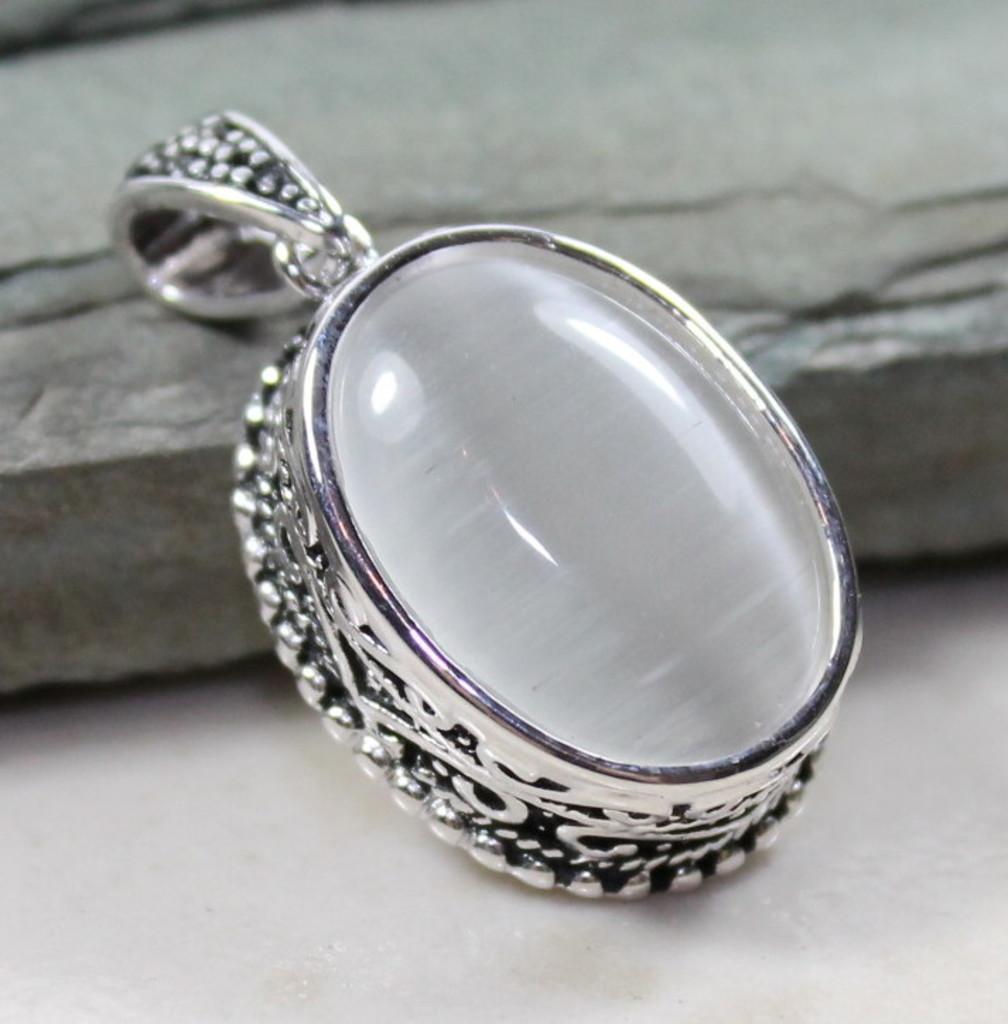Please provide a concise description of this image. In this image we can see a pendant. In the background there is a stone. 